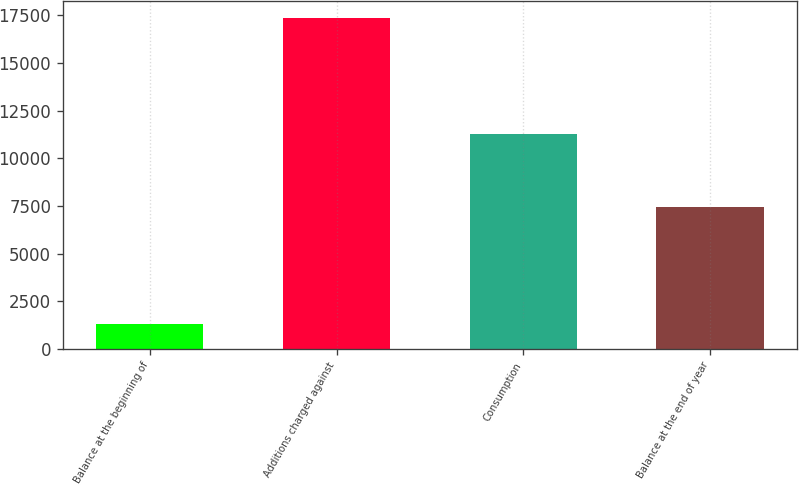Convert chart to OTSL. <chart><loc_0><loc_0><loc_500><loc_500><bar_chart><fcel>Balance at the beginning of<fcel>Additions charged against<fcel>Consumption<fcel>Balance at the end of year<nl><fcel>1317<fcel>17371<fcel>11265<fcel>7423<nl></chart> 